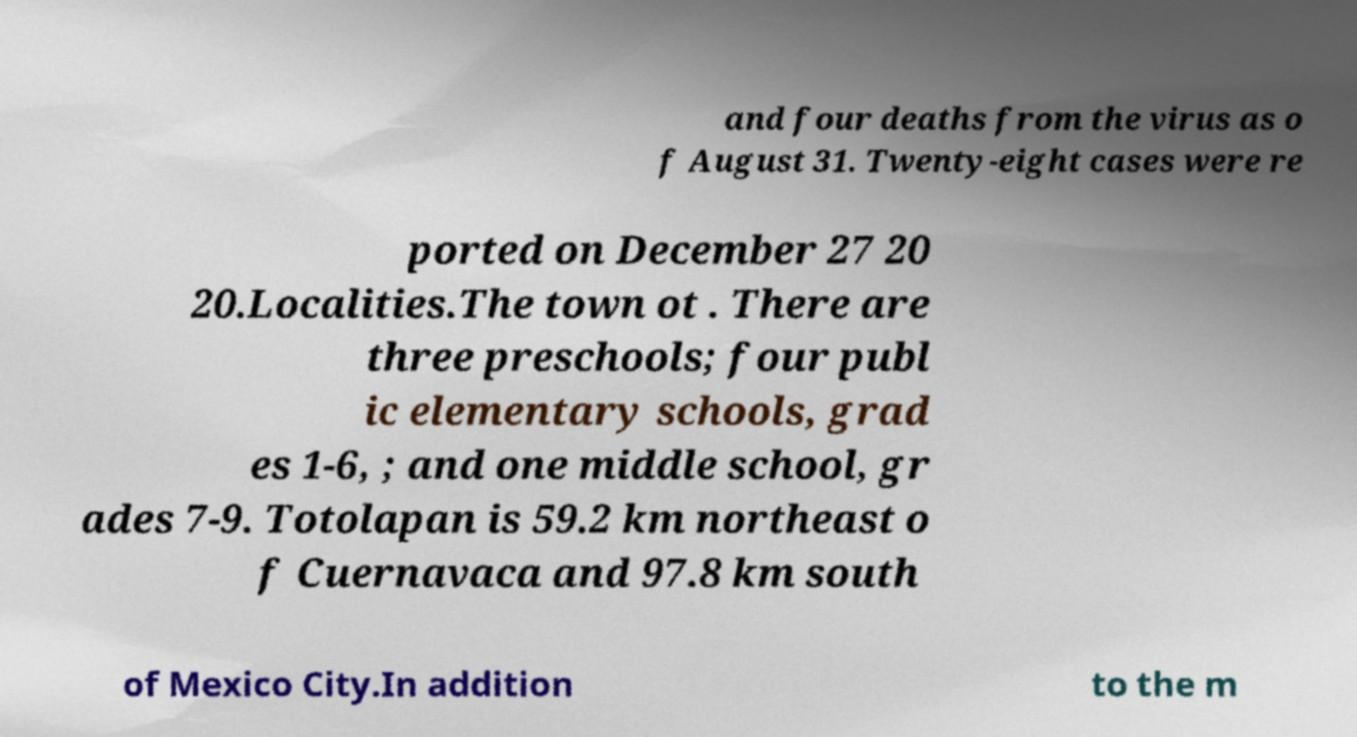Please identify and transcribe the text found in this image. and four deaths from the virus as o f August 31. Twenty-eight cases were re ported on December 27 20 20.Localities.The town ot . There are three preschools; four publ ic elementary schools, grad es 1-6, ; and one middle school, gr ades 7-9. Totolapan is 59.2 km northeast o f Cuernavaca and 97.8 km south of Mexico City.In addition to the m 